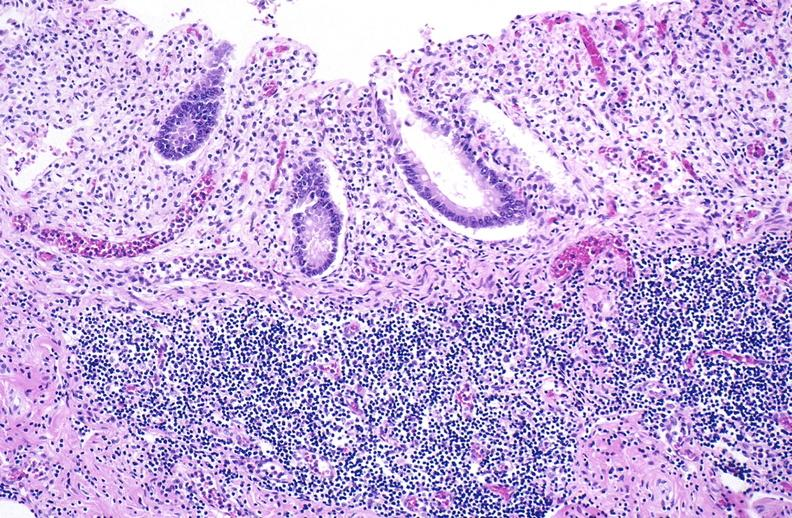s gastrointestinal present?
Answer the question using a single word or phrase. Yes 